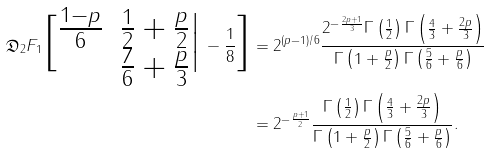Convert formula to latex. <formula><loc_0><loc_0><loc_500><loc_500>\mathfrak { D } _ { 2 } F _ { 1 } \Big [ \begin{matrix} \frac { 1 - p } 6 & \frac { 1 } { 2 } + \frac { p } 2 \\ & \frac { 7 } { 6 } + \frac { p } 3 \end{matrix} \Big | \, - \frac { 1 } { 8 } \Big ] & = 2 ^ { ( p - 1 ) / 6 } \frac { 2 ^ { - \frac { 2 p + 1 } 3 } \Gamma \left ( \frac { 1 } { 2 } \right ) \Gamma \left ( \frac { 4 } { 3 } + \frac { 2 p } 3 \right ) } { \Gamma \left ( 1 + \frac { p } 2 \right ) \Gamma \left ( \frac { 5 } { 6 } + \frac { p } 6 \right ) } \\ & = 2 ^ { - \frac { p + 1 } 2 } \frac { \Gamma \left ( \frac { 1 } { 2 } \right ) \Gamma \left ( \frac { 4 } { 3 } + \frac { 2 p } 3 \right ) } { \Gamma \left ( 1 + \frac { p } 2 \right ) \Gamma \left ( \frac { 5 } { 6 } + \frac { p } 6 \right ) } .</formula> 